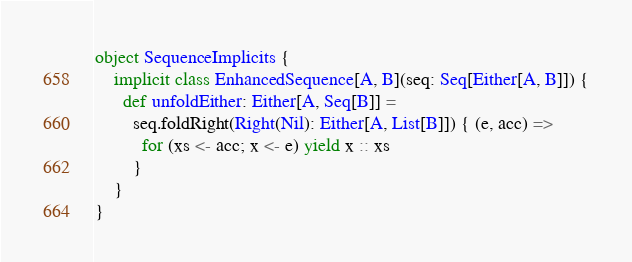Convert code to text. <code><loc_0><loc_0><loc_500><loc_500><_Scala_>object SequenceImplicits {
    implicit class EnhancedSequence[A, B](seq: Seq[Either[A, B]]) {
      def unfoldEither: Either[A, Seq[B]] =
        seq.foldRight(Right(Nil): Either[A, List[B]]) { (e, acc) =>
          for (xs <- acc; x <- e) yield x :: xs
        }
    }
}
</code> 